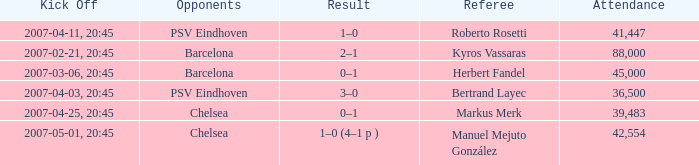WHAT WAS THE SCORE OF THE GAME WITH A 2007-03-06, 20:45 KICKOFF? 0–1. 